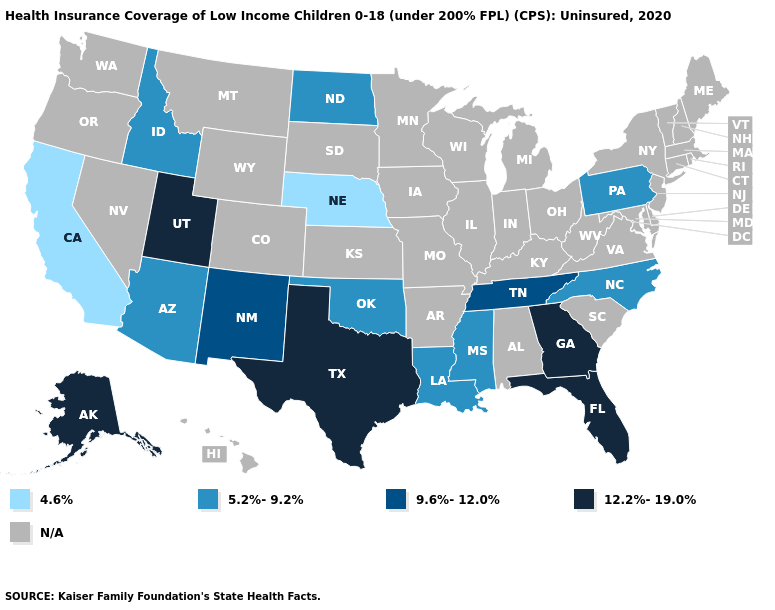Does New Mexico have the highest value in the West?
Quick response, please. No. Name the states that have a value in the range N/A?
Concise answer only. Alabama, Arkansas, Colorado, Connecticut, Delaware, Hawaii, Illinois, Indiana, Iowa, Kansas, Kentucky, Maine, Maryland, Massachusetts, Michigan, Minnesota, Missouri, Montana, Nevada, New Hampshire, New Jersey, New York, Ohio, Oregon, Rhode Island, South Carolina, South Dakota, Vermont, Virginia, Washington, West Virginia, Wisconsin, Wyoming. Which states have the lowest value in the USA?
Give a very brief answer. California, Nebraska. Name the states that have a value in the range 12.2%-19.0%?
Keep it brief. Alaska, Florida, Georgia, Texas, Utah. Name the states that have a value in the range 9.6%-12.0%?
Write a very short answer. New Mexico, Tennessee. Does the first symbol in the legend represent the smallest category?
Be succinct. Yes. Among the states that border Arizona , which have the lowest value?
Concise answer only. California. Which states have the highest value in the USA?
Concise answer only. Alaska, Florida, Georgia, Texas, Utah. Name the states that have a value in the range N/A?
Write a very short answer. Alabama, Arkansas, Colorado, Connecticut, Delaware, Hawaii, Illinois, Indiana, Iowa, Kansas, Kentucky, Maine, Maryland, Massachusetts, Michigan, Minnesota, Missouri, Montana, Nevada, New Hampshire, New Jersey, New York, Ohio, Oregon, Rhode Island, South Carolina, South Dakota, Vermont, Virginia, Washington, West Virginia, Wisconsin, Wyoming. What is the value of Massachusetts?
Concise answer only. N/A. Name the states that have a value in the range 5.2%-9.2%?
Be succinct. Arizona, Idaho, Louisiana, Mississippi, North Carolina, North Dakota, Oklahoma, Pennsylvania. What is the lowest value in the USA?
Be succinct. 4.6%. What is the value of Maryland?
Quick response, please. N/A. What is the value of Kansas?
Concise answer only. N/A. 